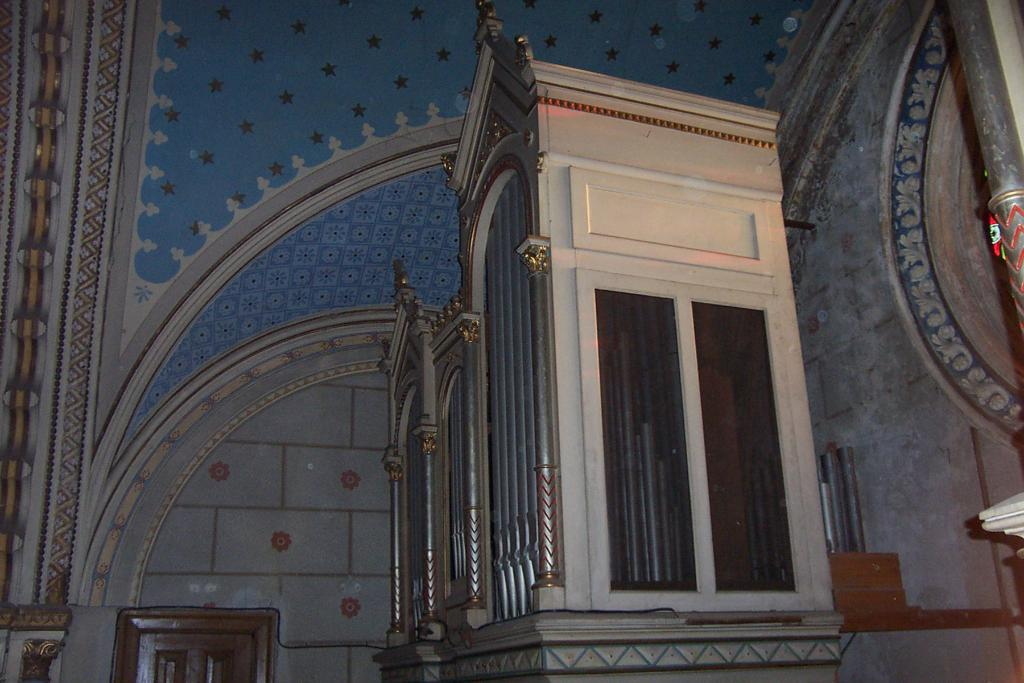What material is the room made of in the image? The room in the image is made of wood. Can you describe the location of the wooden room in the image? The wooden room is near a wall. Where is the door located in the image? There is a door in the bottom left corner of the image. What other structural element can be seen in the image? There is a pillar on the right side of the image. What type of necklace is the person wearing in the image? There is no person or necklace present in the image; it features a wooden room near a wall with a door and a pillar. 